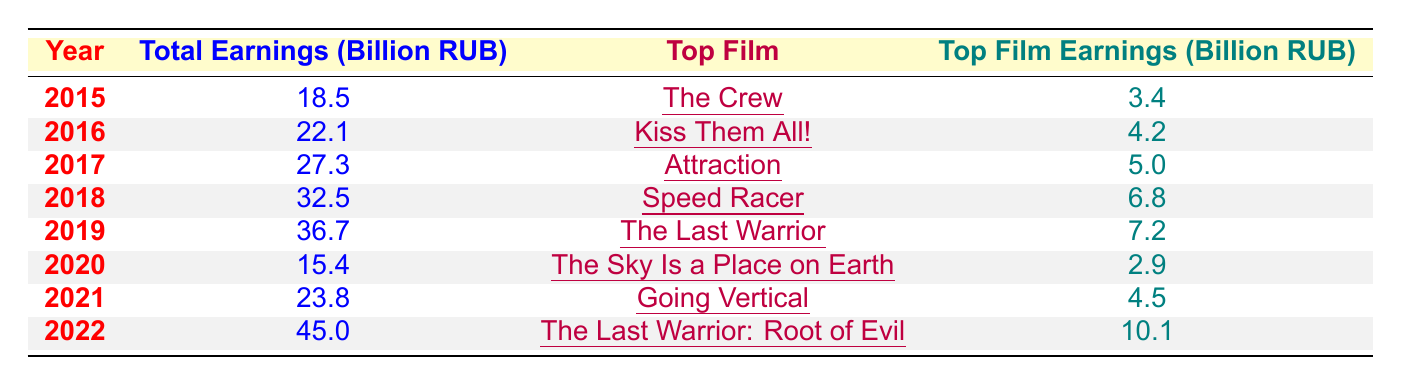What was the total box office earning in 2019? The table shows that the total earnings for the year 2019 are listed as 36.7 billion RUB.
Answer: 36.7 billion RUB Which film had the highest earnings in 2022? According to the table, the film with the highest earnings in 2022 is "The Last Warrior: Root of Evil," which earned 10.1 billion RUB.
Answer: "The Last Warrior: Root of Evil" What is the difference in total earnings between 2015 and 2020? For 2015, the total earnings were 18.5 billion RUB, and for 2020, they were 15.4 billion RUB. The difference is 18.5 - 15.4 = 3.1 billion RUB.
Answer: 3.1 billion RUB What year saw the largest increase in total earnings compared to the previous year? The largest increase in total earnings occurs between 2021 and 2022, going from 23.8 billion RUB to 45.0 billion RUB, an increase of 21.2 billion RUB.
Answer: 2021 to 2022 What is the average total earnings of Russian films from 2015 to 2022? The total earnings for the years are (18.5 + 22.1 + 27.3 + 32.5 + 36.7 + 15.4 + 23.8 + 45.0) = 221.3 billion RUB. There are 8 years, so the average is 221.3 / 8 = 27.66 billion RUB.
Answer: 27.66 billion RUB True or False: The film "Attraction" earned more than 6 billion RUB. The table states that "Attraction" earned 5.0 billion RUB, which is less than 6 billion RUB, making the statement false.
Answer: False How much did the top film in 2018 earn compared to the top film in 2016? The top film in 2018, "Speed Racer," earned 6.8 billion RUB, while the top film in 2016, "Kiss Them All!" earned 4.2 billion RUB. The comparison shows that 6.8 - 4.2 = 2.6 billion RUB more earned by "Speed Racer."
Answer: 2.6 billion RUB What was the total box office earning for Russian films from 2017 to 2019? The total earnings from 2017 to 2019 are 27.3 billion RUB (2017) + 32.5 billion RUB (2018) + 36.7 billion RUB (2019) = 96.5 billion RUB.
Answer: 96.5 billion RUB Which year had the lowest total earnings, and what was that amount? Looking at the table, the year with the lowest total earnings is 2020, with an amount of 15.4 billion RUB.
Answer: 2020, 15.4 billion RUB 